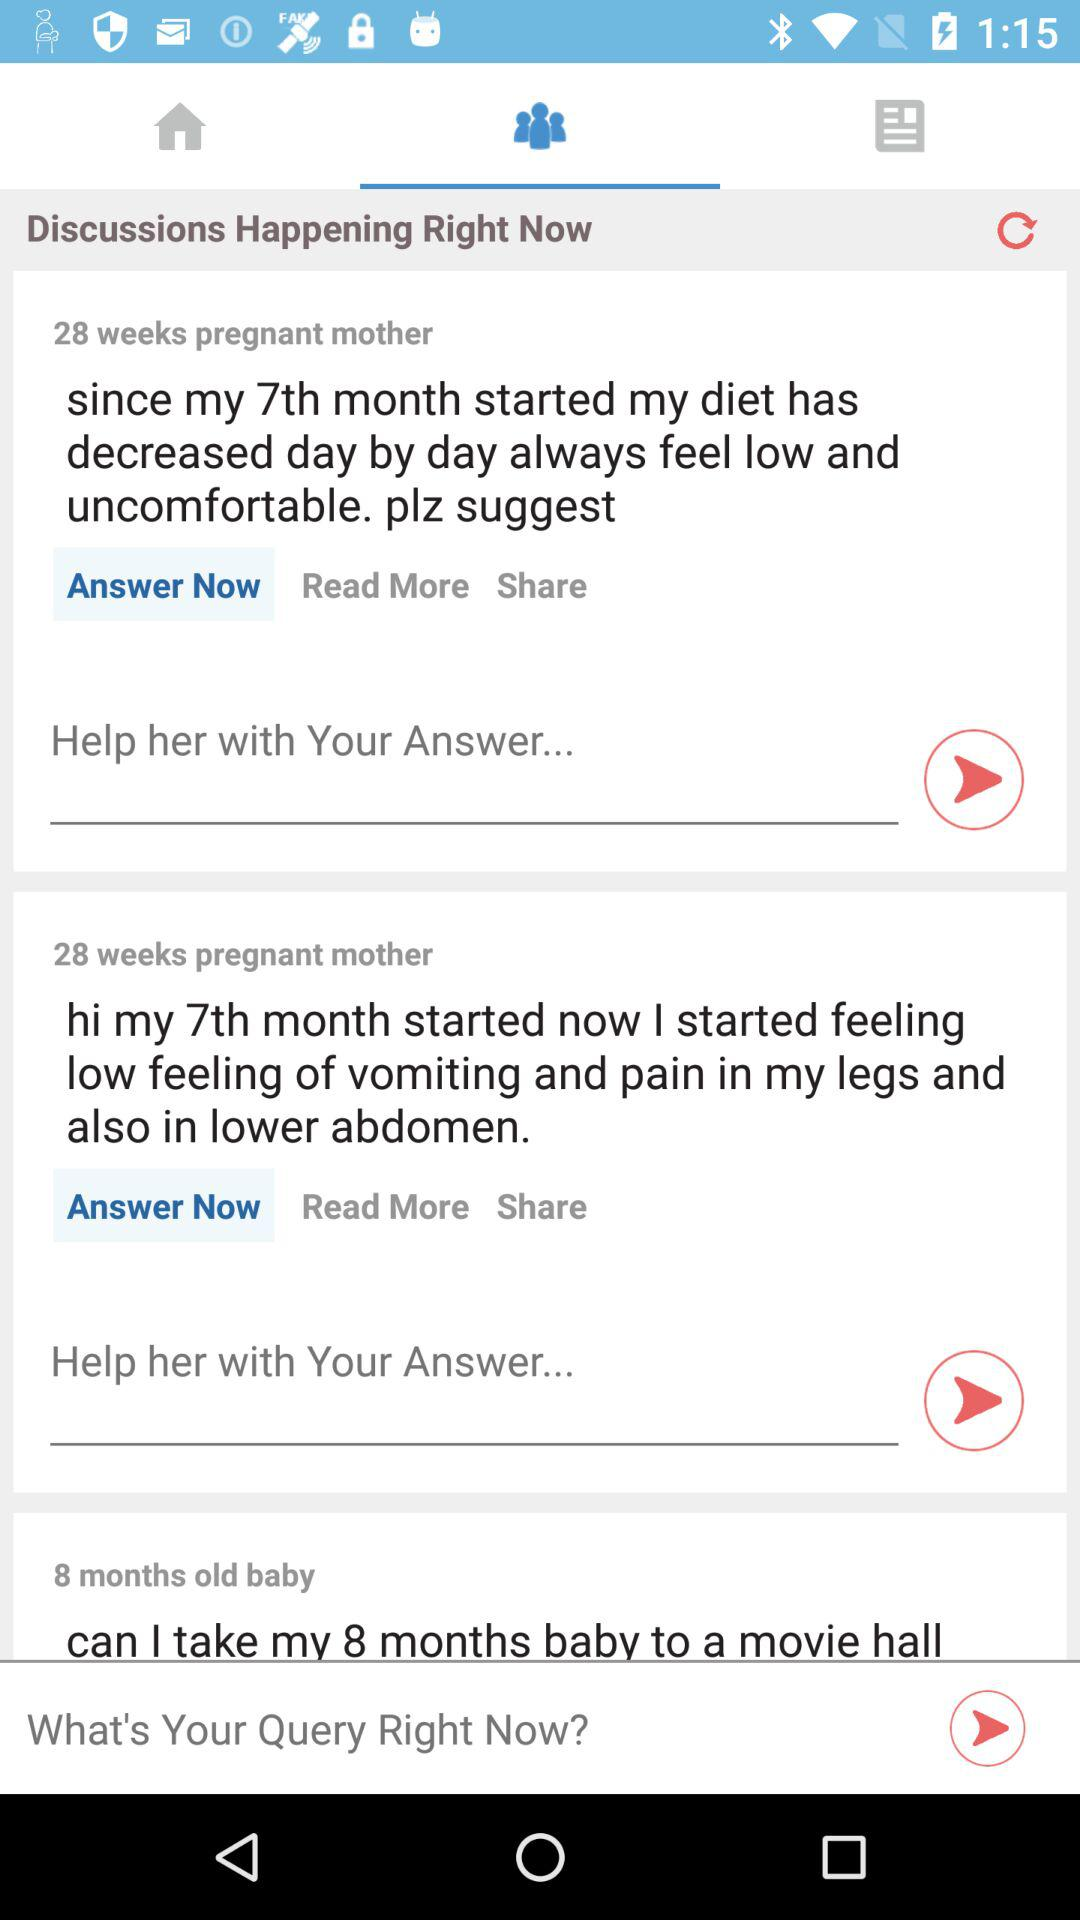What is the time duration of the pregnant mother? The time duration is 28 weeks. 